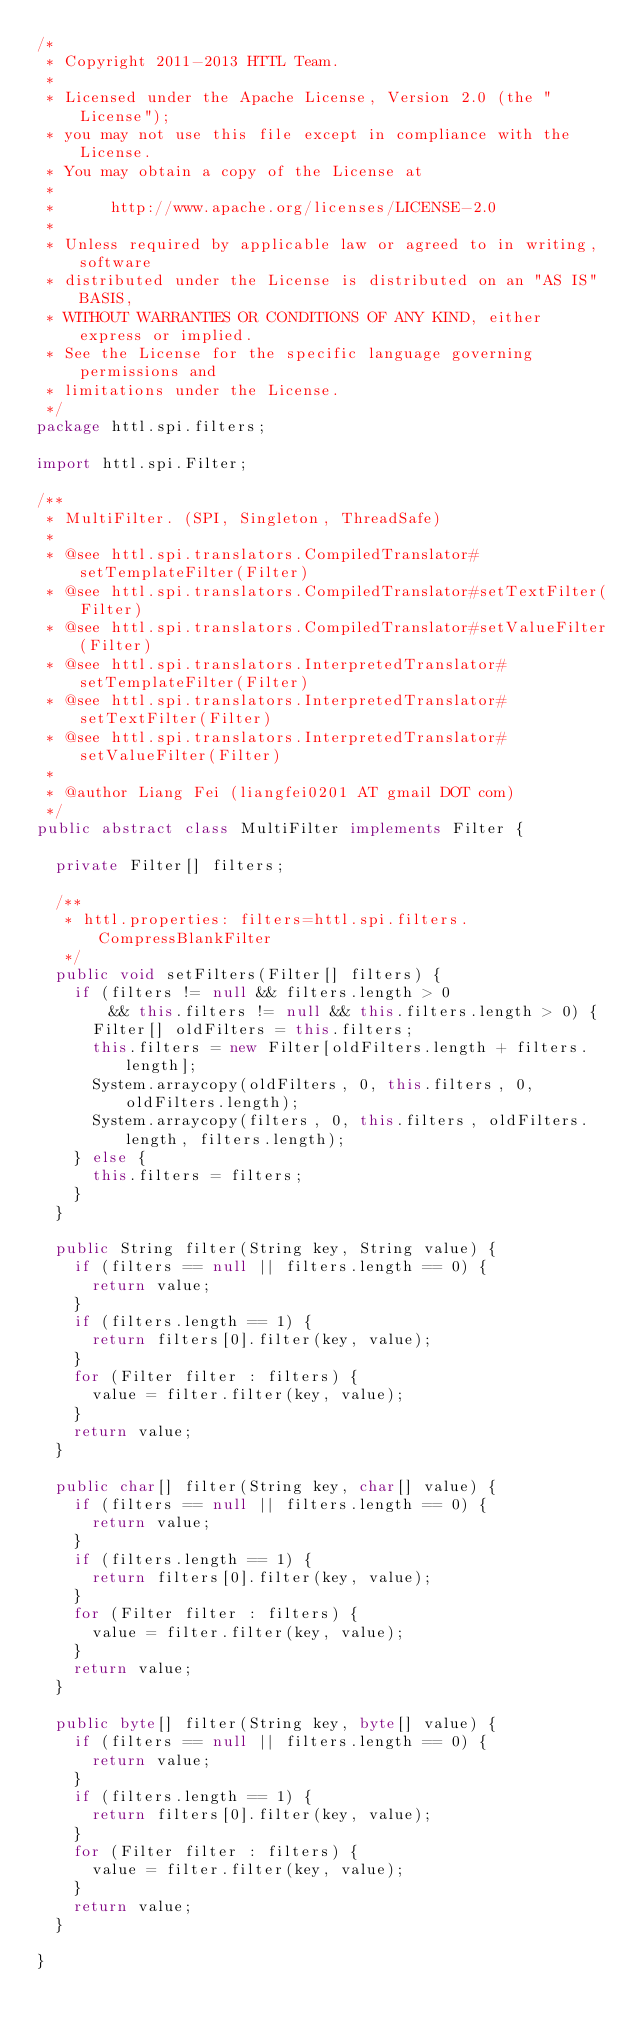Convert code to text. <code><loc_0><loc_0><loc_500><loc_500><_Java_>/*
 * Copyright 2011-2013 HTTL Team.
 *  
 * Licensed under the Apache License, Version 2.0 (the "License");
 * you may not use this file except in compliance with the License.
 * You may obtain a copy of the License at
 *  
 *      http://www.apache.org/licenses/LICENSE-2.0
 *  
 * Unless required by applicable law or agreed to in writing, software
 * distributed under the License is distributed on an "AS IS" BASIS,
 * WITHOUT WARRANTIES OR CONDITIONS OF ANY KIND, either express or implied.
 * See the License for the specific language governing permissions and
 * limitations under the License.
 */
package httl.spi.filters;

import httl.spi.Filter;

/**
 * MultiFilter. (SPI, Singleton, ThreadSafe)
 * 
 * @see httl.spi.translators.CompiledTranslator#setTemplateFilter(Filter)
 * @see httl.spi.translators.CompiledTranslator#setTextFilter(Filter)
 * @see httl.spi.translators.CompiledTranslator#setValueFilter(Filter)
 * @see httl.spi.translators.InterpretedTranslator#setTemplateFilter(Filter)
 * @see httl.spi.translators.InterpretedTranslator#setTextFilter(Filter)
 * @see httl.spi.translators.InterpretedTranslator#setValueFilter(Filter)
 * 
 * @author Liang Fei (liangfei0201 AT gmail DOT com)
 */
public abstract class MultiFilter implements Filter {
	
	private Filter[] filters;
	
	/**
	 * httl.properties: filters=httl.spi.filters.CompressBlankFilter
	 */
	public void setFilters(Filter[] filters) {
		if (filters != null && filters.length > 0 
				&& this.filters != null && this.filters.length > 0) {
			Filter[] oldFilters = this.filters;
			this.filters = new Filter[oldFilters.length + filters.length];
			System.arraycopy(oldFilters, 0, this.filters, 0, oldFilters.length);
			System.arraycopy(filters, 0, this.filters, oldFilters.length, filters.length);
		} else {
			this.filters = filters;
		}
	}

	public String filter(String key, String value) {
		if (filters == null || filters.length == 0) {
			return value;
		}
		if (filters.length == 1) {
			return filters[0].filter(key, value);
		}
		for (Filter filter : filters) {
			value = filter.filter(key, value);
		}
		return value;
	}

	public char[] filter(String key, char[] value) {
		if (filters == null || filters.length == 0) {
			return value;
		}
		if (filters.length == 1) {
			return filters[0].filter(key, value);
		}
		for (Filter filter : filters) {
			value = filter.filter(key, value);
		}
		return value;
	}

	public byte[] filter(String key, byte[] value) {
		if (filters == null || filters.length == 0) {
			return value;
		}
		if (filters.length == 1) {
			return filters[0].filter(key, value);
		}
		for (Filter filter : filters) {
			value = filter.filter(key, value);
		}
		return value;
	}

}</code> 